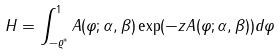<formula> <loc_0><loc_0><loc_500><loc_500>H = \int ^ { 1 } _ { - \varrho ^ { \ast } } A ( \varphi ; \alpha , \beta ) \exp ( - z A ( \varphi ; \alpha , \beta ) ) d \varphi</formula> 